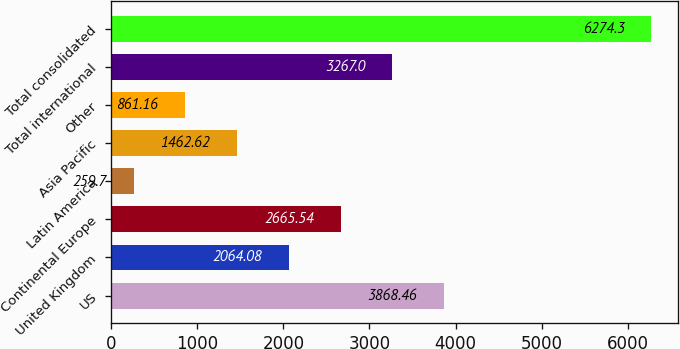<chart> <loc_0><loc_0><loc_500><loc_500><bar_chart><fcel>US<fcel>United Kingdom<fcel>Continental Europe<fcel>Latin America<fcel>Asia Pacific<fcel>Other<fcel>Total international<fcel>Total consolidated<nl><fcel>3868.46<fcel>2064.08<fcel>2665.54<fcel>259.7<fcel>1462.62<fcel>861.16<fcel>3267<fcel>6274.3<nl></chart> 